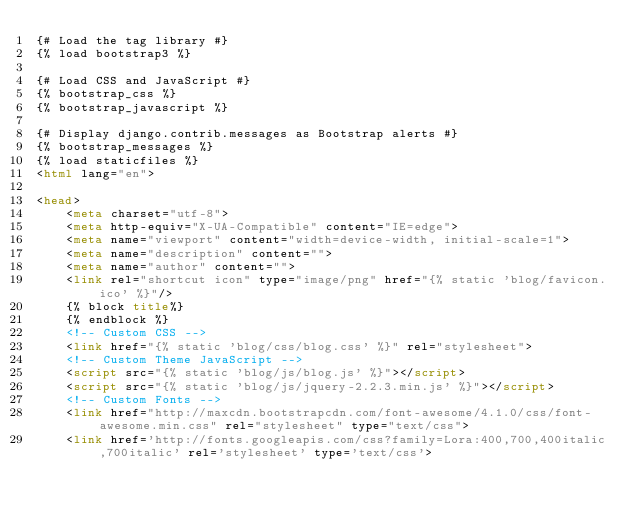<code> <loc_0><loc_0><loc_500><loc_500><_HTML_>{# Load the tag library #}
{% load bootstrap3 %}

{# Load CSS and JavaScript #}
{% bootstrap_css %}
{% bootstrap_javascript %}

{# Display django.contrib.messages as Bootstrap alerts #}
{% bootstrap_messages %}
{% load staticfiles %}
<html lang="en">

<head>
    <meta charset="utf-8">
    <meta http-equiv="X-UA-Compatible" content="IE=edge">
    <meta name="viewport" content="width=device-width, initial-scale=1">
    <meta name="description" content="">
    <meta name="author" content="">
    <link rel="shortcut icon" type="image/png" href="{% static 'blog/favicon.ico' %}"/>
    {% block title%}
    {% endblock %}
	<!-- Custom CSS -->
	<link href="{% static 'blog/css/blog.css' %}" rel="stylesheet">
    <!-- Custom Theme JavaScript -->
    <script src="{% static 'blog/js/blog.js' %}"></script>
    <script src="{% static 'blog/js/jquery-2.2.3.min.js' %}"></script>
    <!-- Custom Fonts -->
    <link href="http://maxcdn.bootstrapcdn.com/font-awesome/4.1.0/css/font-awesome.min.css" rel="stylesheet" type="text/css">
    <link href='http://fonts.googleapis.com/css?family=Lora:400,700,400italic,700italic' rel='stylesheet' type='text/css'></code> 